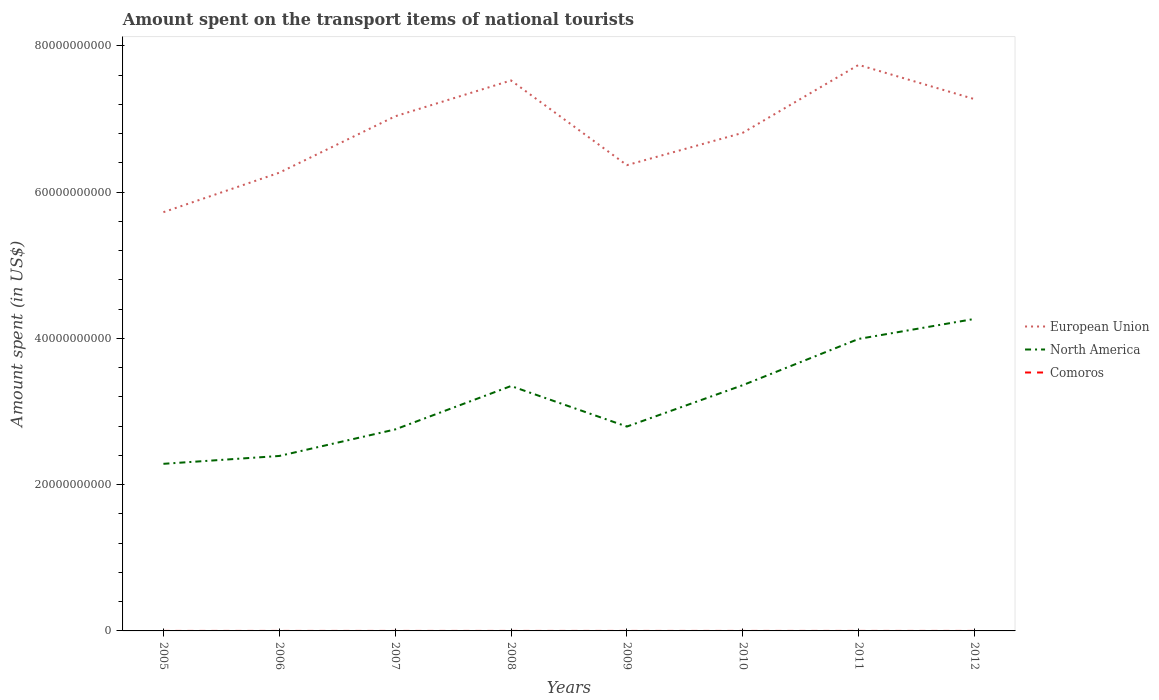Across all years, what is the maximum amount spent on the transport items of national tourists in European Union?
Offer a very short reply. 5.72e+1. In which year was the amount spent on the transport items of national tourists in European Union maximum?
Ensure brevity in your answer.  2005. What is the difference between the highest and the second highest amount spent on the transport items of national tourists in North America?
Offer a very short reply. 1.98e+1. Is the amount spent on the transport items of national tourists in North America strictly greater than the amount spent on the transport items of national tourists in European Union over the years?
Offer a very short reply. Yes. What is the difference between two consecutive major ticks on the Y-axis?
Offer a terse response. 2.00e+1. Are the values on the major ticks of Y-axis written in scientific E-notation?
Your response must be concise. No. Does the graph contain any zero values?
Offer a terse response. No. Does the graph contain grids?
Offer a terse response. No. Where does the legend appear in the graph?
Provide a short and direct response. Center right. How many legend labels are there?
Provide a short and direct response. 3. How are the legend labels stacked?
Your response must be concise. Vertical. What is the title of the graph?
Offer a very short reply. Amount spent on the transport items of national tourists. What is the label or title of the Y-axis?
Offer a very short reply. Amount spent (in US$). What is the Amount spent (in US$) of European Union in 2005?
Provide a short and direct response. 5.72e+1. What is the Amount spent (in US$) in North America in 2005?
Ensure brevity in your answer.  2.28e+1. What is the Amount spent (in US$) in European Union in 2006?
Offer a terse response. 6.26e+1. What is the Amount spent (in US$) in North America in 2006?
Provide a succinct answer. 2.39e+1. What is the Amount spent (in US$) in Comoros in 2006?
Your answer should be compact. 4.00e+05. What is the Amount spent (in US$) of European Union in 2007?
Provide a short and direct response. 7.04e+1. What is the Amount spent (in US$) in North America in 2007?
Your answer should be very brief. 2.75e+1. What is the Amount spent (in US$) in European Union in 2008?
Keep it short and to the point. 7.53e+1. What is the Amount spent (in US$) of North America in 2008?
Ensure brevity in your answer.  3.35e+1. What is the Amount spent (in US$) of Comoros in 2008?
Offer a very short reply. 4.00e+05. What is the Amount spent (in US$) in European Union in 2009?
Ensure brevity in your answer.  6.37e+1. What is the Amount spent (in US$) of North America in 2009?
Provide a succinct answer. 2.79e+1. What is the Amount spent (in US$) in European Union in 2010?
Keep it short and to the point. 6.81e+1. What is the Amount spent (in US$) in North America in 2010?
Give a very brief answer. 3.36e+1. What is the Amount spent (in US$) in Comoros in 2010?
Give a very brief answer. 2.00e+05. What is the Amount spent (in US$) of European Union in 2011?
Offer a very short reply. 7.74e+1. What is the Amount spent (in US$) in North America in 2011?
Your answer should be very brief. 3.99e+1. What is the Amount spent (in US$) of European Union in 2012?
Your response must be concise. 7.27e+1. What is the Amount spent (in US$) in North America in 2012?
Ensure brevity in your answer.  4.27e+1. Across all years, what is the maximum Amount spent (in US$) of European Union?
Your answer should be compact. 7.74e+1. Across all years, what is the maximum Amount spent (in US$) in North America?
Offer a terse response. 4.27e+1. Across all years, what is the maximum Amount spent (in US$) in Comoros?
Offer a very short reply. 4.00e+05. Across all years, what is the minimum Amount spent (in US$) in European Union?
Give a very brief answer. 5.72e+1. Across all years, what is the minimum Amount spent (in US$) of North America?
Provide a short and direct response. 2.28e+1. Across all years, what is the minimum Amount spent (in US$) of Comoros?
Provide a succinct answer. 2.00e+05. What is the total Amount spent (in US$) of European Union in the graph?
Ensure brevity in your answer.  5.47e+11. What is the total Amount spent (in US$) of North America in the graph?
Offer a terse response. 2.52e+11. What is the total Amount spent (in US$) of Comoros in the graph?
Keep it short and to the point. 2.55e+06. What is the difference between the Amount spent (in US$) of European Union in 2005 and that in 2006?
Provide a short and direct response. -5.40e+09. What is the difference between the Amount spent (in US$) of North America in 2005 and that in 2006?
Ensure brevity in your answer.  -1.07e+09. What is the difference between the Amount spent (in US$) in European Union in 2005 and that in 2007?
Make the answer very short. -1.31e+1. What is the difference between the Amount spent (in US$) of North America in 2005 and that in 2007?
Give a very brief answer. -4.70e+09. What is the difference between the Amount spent (in US$) in Comoros in 2005 and that in 2007?
Your answer should be compact. 0. What is the difference between the Amount spent (in US$) in European Union in 2005 and that in 2008?
Make the answer very short. -1.80e+1. What is the difference between the Amount spent (in US$) of North America in 2005 and that in 2008?
Your answer should be compact. -1.06e+1. What is the difference between the Amount spent (in US$) in Comoros in 2005 and that in 2008?
Your answer should be compact. 0. What is the difference between the Amount spent (in US$) in European Union in 2005 and that in 2009?
Ensure brevity in your answer.  -6.43e+09. What is the difference between the Amount spent (in US$) in North America in 2005 and that in 2009?
Your answer should be very brief. -5.09e+09. What is the difference between the Amount spent (in US$) of European Union in 2005 and that in 2010?
Give a very brief answer. -1.08e+1. What is the difference between the Amount spent (in US$) of North America in 2005 and that in 2010?
Your response must be concise. -1.08e+1. What is the difference between the Amount spent (in US$) in Comoros in 2005 and that in 2010?
Make the answer very short. 2.00e+05. What is the difference between the Amount spent (in US$) in European Union in 2005 and that in 2011?
Make the answer very short. -2.01e+1. What is the difference between the Amount spent (in US$) in North America in 2005 and that in 2011?
Your answer should be very brief. -1.71e+1. What is the difference between the Amount spent (in US$) of European Union in 2005 and that in 2012?
Your answer should be compact. -1.55e+1. What is the difference between the Amount spent (in US$) in North America in 2005 and that in 2012?
Offer a terse response. -1.98e+1. What is the difference between the Amount spent (in US$) of Comoros in 2005 and that in 2012?
Ensure brevity in your answer.  1.00e+05. What is the difference between the Amount spent (in US$) of European Union in 2006 and that in 2007?
Your response must be concise. -7.71e+09. What is the difference between the Amount spent (in US$) in North America in 2006 and that in 2007?
Keep it short and to the point. -3.63e+09. What is the difference between the Amount spent (in US$) in European Union in 2006 and that in 2008?
Your answer should be very brief. -1.26e+1. What is the difference between the Amount spent (in US$) in North America in 2006 and that in 2008?
Make the answer very short. -9.56e+09. What is the difference between the Amount spent (in US$) of European Union in 2006 and that in 2009?
Your answer should be very brief. -1.03e+09. What is the difference between the Amount spent (in US$) of North America in 2006 and that in 2009?
Provide a succinct answer. -4.02e+09. What is the difference between the Amount spent (in US$) of European Union in 2006 and that in 2010?
Make the answer very short. -5.45e+09. What is the difference between the Amount spent (in US$) of North America in 2006 and that in 2010?
Provide a short and direct response. -9.68e+09. What is the difference between the Amount spent (in US$) in Comoros in 2006 and that in 2010?
Give a very brief answer. 2.00e+05. What is the difference between the Amount spent (in US$) in European Union in 2006 and that in 2011?
Keep it short and to the point. -1.47e+1. What is the difference between the Amount spent (in US$) in North America in 2006 and that in 2011?
Your answer should be very brief. -1.60e+1. What is the difference between the Amount spent (in US$) of European Union in 2006 and that in 2012?
Your answer should be compact. -1.01e+1. What is the difference between the Amount spent (in US$) in North America in 2006 and that in 2012?
Give a very brief answer. -1.87e+1. What is the difference between the Amount spent (in US$) in Comoros in 2006 and that in 2012?
Give a very brief answer. 1.00e+05. What is the difference between the Amount spent (in US$) in European Union in 2007 and that in 2008?
Your answer should be compact. -4.90e+09. What is the difference between the Amount spent (in US$) in North America in 2007 and that in 2008?
Make the answer very short. -5.94e+09. What is the difference between the Amount spent (in US$) of Comoros in 2007 and that in 2008?
Offer a very short reply. 0. What is the difference between the Amount spent (in US$) in European Union in 2007 and that in 2009?
Provide a succinct answer. 6.68e+09. What is the difference between the Amount spent (in US$) of North America in 2007 and that in 2009?
Ensure brevity in your answer.  -3.94e+08. What is the difference between the Amount spent (in US$) of European Union in 2007 and that in 2010?
Provide a succinct answer. 2.26e+09. What is the difference between the Amount spent (in US$) in North America in 2007 and that in 2010?
Give a very brief answer. -6.05e+09. What is the difference between the Amount spent (in US$) of Comoros in 2007 and that in 2010?
Offer a terse response. 2.00e+05. What is the difference between the Amount spent (in US$) of European Union in 2007 and that in 2011?
Keep it short and to the point. -7.03e+09. What is the difference between the Amount spent (in US$) of North America in 2007 and that in 2011?
Your answer should be compact. -1.24e+1. What is the difference between the Amount spent (in US$) in Comoros in 2007 and that in 2011?
Your answer should be very brief. 2.00e+05. What is the difference between the Amount spent (in US$) of European Union in 2007 and that in 2012?
Make the answer very short. -2.35e+09. What is the difference between the Amount spent (in US$) in North America in 2007 and that in 2012?
Keep it short and to the point. -1.51e+1. What is the difference between the Amount spent (in US$) in Comoros in 2007 and that in 2012?
Offer a very short reply. 1.00e+05. What is the difference between the Amount spent (in US$) in European Union in 2008 and that in 2009?
Provide a short and direct response. 1.16e+1. What is the difference between the Amount spent (in US$) in North America in 2008 and that in 2009?
Your answer should be compact. 5.54e+09. What is the difference between the Amount spent (in US$) of Comoros in 2008 and that in 2009?
Your response must be concise. 1.50e+05. What is the difference between the Amount spent (in US$) of European Union in 2008 and that in 2010?
Your answer should be compact. 7.16e+09. What is the difference between the Amount spent (in US$) in North America in 2008 and that in 2010?
Your answer should be very brief. -1.16e+08. What is the difference between the Amount spent (in US$) in European Union in 2008 and that in 2011?
Offer a very short reply. -2.13e+09. What is the difference between the Amount spent (in US$) in North America in 2008 and that in 2011?
Offer a terse response. -6.44e+09. What is the difference between the Amount spent (in US$) of European Union in 2008 and that in 2012?
Give a very brief answer. 2.56e+09. What is the difference between the Amount spent (in US$) of North America in 2008 and that in 2012?
Your response must be concise. -9.17e+09. What is the difference between the Amount spent (in US$) of European Union in 2009 and that in 2010?
Keep it short and to the point. -4.42e+09. What is the difference between the Amount spent (in US$) in North America in 2009 and that in 2010?
Offer a very short reply. -5.66e+09. What is the difference between the Amount spent (in US$) of Comoros in 2009 and that in 2010?
Your response must be concise. 5.00e+04. What is the difference between the Amount spent (in US$) of European Union in 2009 and that in 2011?
Keep it short and to the point. -1.37e+1. What is the difference between the Amount spent (in US$) in North America in 2009 and that in 2011?
Offer a very short reply. -1.20e+1. What is the difference between the Amount spent (in US$) in Comoros in 2009 and that in 2011?
Provide a short and direct response. 5.00e+04. What is the difference between the Amount spent (in US$) in European Union in 2009 and that in 2012?
Your answer should be compact. -9.02e+09. What is the difference between the Amount spent (in US$) of North America in 2009 and that in 2012?
Keep it short and to the point. -1.47e+1. What is the difference between the Amount spent (in US$) in European Union in 2010 and that in 2011?
Give a very brief answer. -9.29e+09. What is the difference between the Amount spent (in US$) of North America in 2010 and that in 2011?
Ensure brevity in your answer.  -6.32e+09. What is the difference between the Amount spent (in US$) of Comoros in 2010 and that in 2011?
Your answer should be compact. 0. What is the difference between the Amount spent (in US$) of European Union in 2010 and that in 2012?
Make the answer very short. -4.60e+09. What is the difference between the Amount spent (in US$) of North America in 2010 and that in 2012?
Keep it short and to the point. -9.06e+09. What is the difference between the Amount spent (in US$) of European Union in 2011 and that in 2012?
Offer a terse response. 4.68e+09. What is the difference between the Amount spent (in US$) in North America in 2011 and that in 2012?
Offer a very short reply. -2.73e+09. What is the difference between the Amount spent (in US$) of Comoros in 2011 and that in 2012?
Ensure brevity in your answer.  -1.00e+05. What is the difference between the Amount spent (in US$) in European Union in 2005 and the Amount spent (in US$) in North America in 2006?
Make the answer very short. 3.33e+1. What is the difference between the Amount spent (in US$) in European Union in 2005 and the Amount spent (in US$) in Comoros in 2006?
Keep it short and to the point. 5.72e+1. What is the difference between the Amount spent (in US$) in North America in 2005 and the Amount spent (in US$) in Comoros in 2006?
Ensure brevity in your answer.  2.28e+1. What is the difference between the Amount spent (in US$) of European Union in 2005 and the Amount spent (in US$) of North America in 2007?
Your answer should be very brief. 2.97e+1. What is the difference between the Amount spent (in US$) of European Union in 2005 and the Amount spent (in US$) of Comoros in 2007?
Offer a terse response. 5.72e+1. What is the difference between the Amount spent (in US$) of North America in 2005 and the Amount spent (in US$) of Comoros in 2007?
Provide a short and direct response. 2.28e+1. What is the difference between the Amount spent (in US$) in European Union in 2005 and the Amount spent (in US$) in North America in 2008?
Offer a very short reply. 2.38e+1. What is the difference between the Amount spent (in US$) of European Union in 2005 and the Amount spent (in US$) of Comoros in 2008?
Your answer should be very brief. 5.72e+1. What is the difference between the Amount spent (in US$) of North America in 2005 and the Amount spent (in US$) of Comoros in 2008?
Your answer should be very brief. 2.28e+1. What is the difference between the Amount spent (in US$) in European Union in 2005 and the Amount spent (in US$) in North America in 2009?
Ensure brevity in your answer.  2.93e+1. What is the difference between the Amount spent (in US$) in European Union in 2005 and the Amount spent (in US$) in Comoros in 2009?
Your answer should be very brief. 5.72e+1. What is the difference between the Amount spent (in US$) in North America in 2005 and the Amount spent (in US$) in Comoros in 2009?
Give a very brief answer. 2.28e+1. What is the difference between the Amount spent (in US$) of European Union in 2005 and the Amount spent (in US$) of North America in 2010?
Provide a short and direct response. 2.37e+1. What is the difference between the Amount spent (in US$) of European Union in 2005 and the Amount spent (in US$) of Comoros in 2010?
Give a very brief answer. 5.72e+1. What is the difference between the Amount spent (in US$) of North America in 2005 and the Amount spent (in US$) of Comoros in 2010?
Offer a terse response. 2.28e+1. What is the difference between the Amount spent (in US$) of European Union in 2005 and the Amount spent (in US$) of North America in 2011?
Ensure brevity in your answer.  1.73e+1. What is the difference between the Amount spent (in US$) of European Union in 2005 and the Amount spent (in US$) of Comoros in 2011?
Your answer should be compact. 5.72e+1. What is the difference between the Amount spent (in US$) of North America in 2005 and the Amount spent (in US$) of Comoros in 2011?
Give a very brief answer. 2.28e+1. What is the difference between the Amount spent (in US$) of European Union in 2005 and the Amount spent (in US$) of North America in 2012?
Keep it short and to the point. 1.46e+1. What is the difference between the Amount spent (in US$) in European Union in 2005 and the Amount spent (in US$) in Comoros in 2012?
Your answer should be very brief. 5.72e+1. What is the difference between the Amount spent (in US$) of North America in 2005 and the Amount spent (in US$) of Comoros in 2012?
Offer a very short reply. 2.28e+1. What is the difference between the Amount spent (in US$) in European Union in 2006 and the Amount spent (in US$) in North America in 2007?
Make the answer very short. 3.51e+1. What is the difference between the Amount spent (in US$) of European Union in 2006 and the Amount spent (in US$) of Comoros in 2007?
Provide a succinct answer. 6.26e+1. What is the difference between the Amount spent (in US$) of North America in 2006 and the Amount spent (in US$) of Comoros in 2007?
Keep it short and to the point. 2.39e+1. What is the difference between the Amount spent (in US$) of European Union in 2006 and the Amount spent (in US$) of North America in 2008?
Your answer should be very brief. 2.92e+1. What is the difference between the Amount spent (in US$) of European Union in 2006 and the Amount spent (in US$) of Comoros in 2008?
Offer a terse response. 6.26e+1. What is the difference between the Amount spent (in US$) of North America in 2006 and the Amount spent (in US$) of Comoros in 2008?
Your answer should be compact. 2.39e+1. What is the difference between the Amount spent (in US$) of European Union in 2006 and the Amount spent (in US$) of North America in 2009?
Your response must be concise. 3.47e+1. What is the difference between the Amount spent (in US$) of European Union in 2006 and the Amount spent (in US$) of Comoros in 2009?
Offer a terse response. 6.26e+1. What is the difference between the Amount spent (in US$) of North America in 2006 and the Amount spent (in US$) of Comoros in 2009?
Offer a very short reply. 2.39e+1. What is the difference between the Amount spent (in US$) in European Union in 2006 and the Amount spent (in US$) in North America in 2010?
Offer a terse response. 2.90e+1. What is the difference between the Amount spent (in US$) in European Union in 2006 and the Amount spent (in US$) in Comoros in 2010?
Give a very brief answer. 6.26e+1. What is the difference between the Amount spent (in US$) in North America in 2006 and the Amount spent (in US$) in Comoros in 2010?
Offer a very short reply. 2.39e+1. What is the difference between the Amount spent (in US$) in European Union in 2006 and the Amount spent (in US$) in North America in 2011?
Ensure brevity in your answer.  2.27e+1. What is the difference between the Amount spent (in US$) in European Union in 2006 and the Amount spent (in US$) in Comoros in 2011?
Your answer should be very brief. 6.26e+1. What is the difference between the Amount spent (in US$) in North America in 2006 and the Amount spent (in US$) in Comoros in 2011?
Provide a succinct answer. 2.39e+1. What is the difference between the Amount spent (in US$) of European Union in 2006 and the Amount spent (in US$) of North America in 2012?
Your answer should be very brief. 2.00e+1. What is the difference between the Amount spent (in US$) in European Union in 2006 and the Amount spent (in US$) in Comoros in 2012?
Your answer should be very brief. 6.26e+1. What is the difference between the Amount spent (in US$) of North America in 2006 and the Amount spent (in US$) of Comoros in 2012?
Your answer should be compact. 2.39e+1. What is the difference between the Amount spent (in US$) in European Union in 2007 and the Amount spent (in US$) in North America in 2008?
Keep it short and to the point. 3.69e+1. What is the difference between the Amount spent (in US$) in European Union in 2007 and the Amount spent (in US$) in Comoros in 2008?
Ensure brevity in your answer.  7.04e+1. What is the difference between the Amount spent (in US$) in North America in 2007 and the Amount spent (in US$) in Comoros in 2008?
Your answer should be compact. 2.75e+1. What is the difference between the Amount spent (in US$) in European Union in 2007 and the Amount spent (in US$) in North America in 2009?
Make the answer very short. 4.24e+1. What is the difference between the Amount spent (in US$) in European Union in 2007 and the Amount spent (in US$) in Comoros in 2009?
Keep it short and to the point. 7.04e+1. What is the difference between the Amount spent (in US$) of North America in 2007 and the Amount spent (in US$) of Comoros in 2009?
Your answer should be compact. 2.75e+1. What is the difference between the Amount spent (in US$) of European Union in 2007 and the Amount spent (in US$) of North America in 2010?
Your answer should be compact. 3.68e+1. What is the difference between the Amount spent (in US$) in European Union in 2007 and the Amount spent (in US$) in Comoros in 2010?
Offer a very short reply. 7.04e+1. What is the difference between the Amount spent (in US$) of North America in 2007 and the Amount spent (in US$) of Comoros in 2010?
Offer a very short reply. 2.75e+1. What is the difference between the Amount spent (in US$) of European Union in 2007 and the Amount spent (in US$) of North America in 2011?
Your response must be concise. 3.04e+1. What is the difference between the Amount spent (in US$) of European Union in 2007 and the Amount spent (in US$) of Comoros in 2011?
Keep it short and to the point. 7.04e+1. What is the difference between the Amount spent (in US$) in North America in 2007 and the Amount spent (in US$) in Comoros in 2011?
Give a very brief answer. 2.75e+1. What is the difference between the Amount spent (in US$) in European Union in 2007 and the Amount spent (in US$) in North America in 2012?
Your answer should be very brief. 2.77e+1. What is the difference between the Amount spent (in US$) in European Union in 2007 and the Amount spent (in US$) in Comoros in 2012?
Ensure brevity in your answer.  7.04e+1. What is the difference between the Amount spent (in US$) in North America in 2007 and the Amount spent (in US$) in Comoros in 2012?
Make the answer very short. 2.75e+1. What is the difference between the Amount spent (in US$) in European Union in 2008 and the Amount spent (in US$) in North America in 2009?
Keep it short and to the point. 4.73e+1. What is the difference between the Amount spent (in US$) in European Union in 2008 and the Amount spent (in US$) in Comoros in 2009?
Provide a succinct answer. 7.53e+1. What is the difference between the Amount spent (in US$) in North America in 2008 and the Amount spent (in US$) in Comoros in 2009?
Offer a terse response. 3.35e+1. What is the difference between the Amount spent (in US$) in European Union in 2008 and the Amount spent (in US$) in North America in 2010?
Your answer should be compact. 4.17e+1. What is the difference between the Amount spent (in US$) of European Union in 2008 and the Amount spent (in US$) of Comoros in 2010?
Give a very brief answer. 7.53e+1. What is the difference between the Amount spent (in US$) of North America in 2008 and the Amount spent (in US$) of Comoros in 2010?
Keep it short and to the point. 3.35e+1. What is the difference between the Amount spent (in US$) in European Union in 2008 and the Amount spent (in US$) in North America in 2011?
Your answer should be compact. 3.53e+1. What is the difference between the Amount spent (in US$) of European Union in 2008 and the Amount spent (in US$) of Comoros in 2011?
Make the answer very short. 7.53e+1. What is the difference between the Amount spent (in US$) of North America in 2008 and the Amount spent (in US$) of Comoros in 2011?
Your answer should be compact. 3.35e+1. What is the difference between the Amount spent (in US$) of European Union in 2008 and the Amount spent (in US$) of North America in 2012?
Keep it short and to the point. 3.26e+1. What is the difference between the Amount spent (in US$) of European Union in 2008 and the Amount spent (in US$) of Comoros in 2012?
Your answer should be very brief. 7.53e+1. What is the difference between the Amount spent (in US$) of North America in 2008 and the Amount spent (in US$) of Comoros in 2012?
Your response must be concise. 3.35e+1. What is the difference between the Amount spent (in US$) in European Union in 2009 and the Amount spent (in US$) in North America in 2010?
Your response must be concise. 3.01e+1. What is the difference between the Amount spent (in US$) of European Union in 2009 and the Amount spent (in US$) of Comoros in 2010?
Give a very brief answer. 6.37e+1. What is the difference between the Amount spent (in US$) in North America in 2009 and the Amount spent (in US$) in Comoros in 2010?
Your answer should be compact. 2.79e+1. What is the difference between the Amount spent (in US$) of European Union in 2009 and the Amount spent (in US$) of North America in 2011?
Ensure brevity in your answer.  2.38e+1. What is the difference between the Amount spent (in US$) of European Union in 2009 and the Amount spent (in US$) of Comoros in 2011?
Offer a very short reply. 6.37e+1. What is the difference between the Amount spent (in US$) of North America in 2009 and the Amount spent (in US$) of Comoros in 2011?
Your answer should be very brief. 2.79e+1. What is the difference between the Amount spent (in US$) of European Union in 2009 and the Amount spent (in US$) of North America in 2012?
Give a very brief answer. 2.10e+1. What is the difference between the Amount spent (in US$) of European Union in 2009 and the Amount spent (in US$) of Comoros in 2012?
Make the answer very short. 6.37e+1. What is the difference between the Amount spent (in US$) in North America in 2009 and the Amount spent (in US$) in Comoros in 2012?
Keep it short and to the point. 2.79e+1. What is the difference between the Amount spent (in US$) of European Union in 2010 and the Amount spent (in US$) of North America in 2011?
Your answer should be compact. 2.82e+1. What is the difference between the Amount spent (in US$) of European Union in 2010 and the Amount spent (in US$) of Comoros in 2011?
Ensure brevity in your answer.  6.81e+1. What is the difference between the Amount spent (in US$) in North America in 2010 and the Amount spent (in US$) in Comoros in 2011?
Your answer should be compact. 3.36e+1. What is the difference between the Amount spent (in US$) of European Union in 2010 and the Amount spent (in US$) of North America in 2012?
Ensure brevity in your answer.  2.54e+1. What is the difference between the Amount spent (in US$) of European Union in 2010 and the Amount spent (in US$) of Comoros in 2012?
Provide a short and direct response. 6.81e+1. What is the difference between the Amount spent (in US$) of North America in 2010 and the Amount spent (in US$) of Comoros in 2012?
Give a very brief answer. 3.36e+1. What is the difference between the Amount spent (in US$) in European Union in 2011 and the Amount spent (in US$) in North America in 2012?
Ensure brevity in your answer.  3.47e+1. What is the difference between the Amount spent (in US$) of European Union in 2011 and the Amount spent (in US$) of Comoros in 2012?
Offer a terse response. 7.74e+1. What is the difference between the Amount spent (in US$) in North America in 2011 and the Amount spent (in US$) in Comoros in 2012?
Your response must be concise. 3.99e+1. What is the average Amount spent (in US$) of European Union per year?
Provide a succinct answer. 6.84e+1. What is the average Amount spent (in US$) of North America per year?
Your answer should be very brief. 3.15e+1. What is the average Amount spent (in US$) in Comoros per year?
Make the answer very short. 3.19e+05. In the year 2005, what is the difference between the Amount spent (in US$) in European Union and Amount spent (in US$) in North America?
Make the answer very short. 3.44e+1. In the year 2005, what is the difference between the Amount spent (in US$) in European Union and Amount spent (in US$) in Comoros?
Offer a terse response. 5.72e+1. In the year 2005, what is the difference between the Amount spent (in US$) of North America and Amount spent (in US$) of Comoros?
Make the answer very short. 2.28e+1. In the year 2006, what is the difference between the Amount spent (in US$) in European Union and Amount spent (in US$) in North America?
Offer a very short reply. 3.87e+1. In the year 2006, what is the difference between the Amount spent (in US$) of European Union and Amount spent (in US$) of Comoros?
Offer a very short reply. 6.26e+1. In the year 2006, what is the difference between the Amount spent (in US$) of North America and Amount spent (in US$) of Comoros?
Offer a terse response. 2.39e+1. In the year 2007, what is the difference between the Amount spent (in US$) of European Union and Amount spent (in US$) of North America?
Provide a short and direct response. 4.28e+1. In the year 2007, what is the difference between the Amount spent (in US$) in European Union and Amount spent (in US$) in Comoros?
Provide a short and direct response. 7.04e+1. In the year 2007, what is the difference between the Amount spent (in US$) in North America and Amount spent (in US$) in Comoros?
Your response must be concise. 2.75e+1. In the year 2008, what is the difference between the Amount spent (in US$) in European Union and Amount spent (in US$) in North America?
Make the answer very short. 4.18e+1. In the year 2008, what is the difference between the Amount spent (in US$) in European Union and Amount spent (in US$) in Comoros?
Offer a very short reply. 7.53e+1. In the year 2008, what is the difference between the Amount spent (in US$) of North America and Amount spent (in US$) of Comoros?
Your response must be concise. 3.35e+1. In the year 2009, what is the difference between the Amount spent (in US$) in European Union and Amount spent (in US$) in North America?
Ensure brevity in your answer.  3.57e+1. In the year 2009, what is the difference between the Amount spent (in US$) of European Union and Amount spent (in US$) of Comoros?
Ensure brevity in your answer.  6.37e+1. In the year 2009, what is the difference between the Amount spent (in US$) of North America and Amount spent (in US$) of Comoros?
Provide a short and direct response. 2.79e+1. In the year 2010, what is the difference between the Amount spent (in US$) in European Union and Amount spent (in US$) in North America?
Offer a very short reply. 3.45e+1. In the year 2010, what is the difference between the Amount spent (in US$) of European Union and Amount spent (in US$) of Comoros?
Your answer should be compact. 6.81e+1. In the year 2010, what is the difference between the Amount spent (in US$) in North America and Amount spent (in US$) in Comoros?
Provide a succinct answer. 3.36e+1. In the year 2011, what is the difference between the Amount spent (in US$) of European Union and Amount spent (in US$) of North America?
Your answer should be very brief. 3.75e+1. In the year 2011, what is the difference between the Amount spent (in US$) in European Union and Amount spent (in US$) in Comoros?
Your answer should be very brief. 7.74e+1. In the year 2011, what is the difference between the Amount spent (in US$) of North America and Amount spent (in US$) of Comoros?
Provide a short and direct response. 3.99e+1. In the year 2012, what is the difference between the Amount spent (in US$) in European Union and Amount spent (in US$) in North America?
Your response must be concise. 3.00e+1. In the year 2012, what is the difference between the Amount spent (in US$) in European Union and Amount spent (in US$) in Comoros?
Provide a short and direct response. 7.27e+1. In the year 2012, what is the difference between the Amount spent (in US$) of North America and Amount spent (in US$) of Comoros?
Your response must be concise. 4.27e+1. What is the ratio of the Amount spent (in US$) of European Union in 2005 to that in 2006?
Offer a very short reply. 0.91. What is the ratio of the Amount spent (in US$) in North America in 2005 to that in 2006?
Your response must be concise. 0.96. What is the ratio of the Amount spent (in US$) of European Union in 2005 to that in 2007?
Your answer should be compact. 0.81. What is the ratio of the Amount spent (in US$) in North America in 2005 to that in 2007?
Make the answer very short. 0.83. What is the ratio of the Amount spent (in US$) in Comoros in 2005 to that in 2007?
Your response must be concise. 1. What is the ratio of the Amount spent (in US$) in European Union in 2005 to that in 2008?
Give a very brief answer. 0.76. What is the ratio of the Amount spent (in US$) in North America in 2005 to that in 2008?
Your answer should be very brief. 0.68. What is the ratio of the Amount spent (in US$) of European Union in 2005 to that in 2009?
Provide a short and direct response. 0.9. What is the ratio of the Amount spent (in US$) of North America in 2005 to that in 2009?
Offer a terse response. 0.82. What is the ratio of the Amount spent (in US$) of European Union in 2005 to that in 2010?
Offer a terse response. 0.84. What is the ratio of the Amount spent (in US$) in North America in 2005 to that in 2010?
Make the answer very short. 0.68. What is the ratio of the Amount spent (in US$) in European Union in 2005 to that in 2011?
Make the answer very short. 0.74. What is the ratio of the Amount spent (in US$) of North America in 2005 to that in 2011?
Your answer should be very brief. 0.57. What is the ratio of the Amount spent (in US$) of European Union in 2005 to that in 2012?
Make the answer very short. 0.79. What is the ratio of the Amount spent (in US$) of North America in 2005 to that in 2012?
Your answer should be compact. 0.54. What is the ratio of the Amount spent (in US$) in Comoros in 2005 to that in 2012?
Provide a short and direct response. 1.33. What is the ratio of the Amount spent (in US$) in European Union in 2006 to that in 2007?
Your answer should be very brief. 0.89. What is the ratio of the Amount spent (in US$) of North America in 2006 to that in 2007?
Your answer should be compact. 0.87. What is the ratio of the Amount spent (in US$) of European Union in 2006 to that in 2008?
Make the answer very short. 0.83. What is the ratio of the Amount spent (in US$) in North America in 2006 to that in 2008?
Your answer should be compact. 0.71. What is the ratio of the Amount spent (in US$) of Comoros in 2006 to that in 2008?
Provide a short and direct response. 1. What is the ratio of the Amount spent (in US$) in European Union in 2006 to that in 2009?
Make the answer very short. 0.98. What is the ratio of the Amount spent (in US$) of North America in 2006 to that in 2009?
Your answer should be very brief. 0.86. What is the ratio of the Amount spent (in US$) of Comoros in 2006 to that in 2009?
Keep it short and to the point. 1.6. What is the ratio of the Amount spent (in US$) in European Union in 2006 to that in 2010?
Provide a short and direct response. 0.92. What is the ratio of the Amount spent (in US$) in North America in 2006 to that in 2010?
Provide a succinct answer. 0.71. What is the ratio of the Amount spent (in US$) of European Union in 2006 to that in 2011?
Ensure brevity in your answer.  0.81. What is the ratio of the Amount spent (in US$) of North America in 2006 to that in 2011?
Give a very brief answer. 0.6. What is the ratio of the Amount spent (in US$) of Comoros in 2006 to that in 2011?
Keep it short and to the point. 2. What is the ratio of the Amount spent (in US$) in European Union in 2006 to that in 2012?
Provide a succinct answer. 0.86. What is the ratio of the Amount spent (in US$) in North America in 2006 to that in 2012?
Your response must be concise. 0.56. What is the ratio of the Amount spent (in US$) of European Union in 2007 to that in 2008?
Offer a very short reply. 0.93. What is the ratio of the Amount spent (in US$) in North America in 2007 to that in 2008?
Make the answer very short. 0.82. What is the ratio of the Amount spent (in US$) of European Union in 2007 to that in 2009?
Offer a terse response. 1.1. What is the ratio of the Amount spent (in US$) of North America in 2007 to that in 2009?
Give a very brief answer. 0.99. What is the ratio of the Amount spent (in US$) in Comoros in 2007 to that in 2009?
Offer a very short reply. 1.6. What is the ratio of the Amount spent (in US$) in European Union in 2007 to that in 2010?
Provide a succinct answer. 1.03. What is the ratio of the Amount spent (in US$) in North America in 2007 to that in 2010?
Ensure brevity in your answer.  0.82. What is the ratio of the Amount spent (in US$) of Comoros in 2007 to that in 2010?
Keep it short and to the point. 2. What is the ratio of the Amount spent (in US$) of European Union in 2007 to that in 2011?
Provide a succinct answer. 0.91. What is the ratio of the Amount spent (in US$) in North America in 2007 to that in 2011?
Provide a succinct answer. 0.69. What is the ratio of the Amount spent (in US$) of Comoros in 2007 to that in 2011?
Keep it short and to the point. 2. What is the ratio of the Amount spent (in US$) of North America in 2007 to that in 2012?
Ensure brevity in your answer.  0.65. What is the ratio of the Amount spent (in US$) in Comoros in 2007 to that in 2012?
Keep it short and to the point. 1.33. What is the ratio of the Amount spent (in US$) in European Union in 2008 to that in 2009?
Provide a short and direct response. 1.18. What is the ratio of the Amount spent (in US$) of North America in 2008 to that in 2009?
Your response must be concise. 1.2. What is the ratio of the Amount spent (in US$) of Comoros in 2008 to that in 2009?
Your response must be concise. 1.6. What is the ratio of the Amount spent (in US$) of European Union in 2008 to that in 2010?
Make the answer very short. 1.11. What is the ratio of the Amount spent (in US$) in North America in 2008 to that in 2010?
Provide a succinct answer. 1. What is the ratio of the Amount spent (in US$) of European Union in 2008 to that in 2011?
Keep it short and to the point. 0.97. What is the ratio of the Amount spent (in US$) of North America in 2008 to that in 2011?
Your answer should be very brief. 0.84. What is the ratio of the Amount spent (in US$) of Comoros in 2008 to that in 2011?
Make the answer very short. 2. What is the ratio of the Amount spent (in US$) of European Union in 2008 to that in 2012?
Your answer should be compact. 1.04. What is the ratio of the Amount spent (in US$) of North America in 2008 to that in 2012?
Provide a succinct answer. 0.78. What is the ratio of the Amount spent (in US$) in European Union in 2009 to that in 2010?
Provide a succinct answer. 0.94. What is the ratio of the Amount spent (in US$) in North America in 2009 to that in 2010?
Give a very brief answer. 0.83. What is the ratio of the Amount spent (in US$) of European Union in 2009 to that in 2011?
Your answer should be compact. 0.82. What is the ratio of the Amount spent (in US$) in North America in 2009 to that in 2011?
Your answer should be very brief. 0.7. What is the ratio of the Amount spent (in US$) of European Union in 2009 to that in 2012?
Offer a very short reply. 0.88. What is the ratio of the Amount spent (in US$) of North America in 2009 to that in 2012?
Provide a short and direct response. 0.66. What is the ratio of the Amount spent (in US$) of Comoros in 2009 to that in 2012?
Offer a terse response. 0.83. What is the ratio of the Amount spent (in US$) of European Union in 2010 to that in 2011?
Offer a very short reply. 0.88. What is the ratio of the Amount spent (in US$) of North America in 2010 to that in 2011?
Provide a short and direct response. 0.84. What is the ratio of the Amount spent (in US$) in Comoros in 2010 to that in 2011?
Keep it short and to the point. 1. What is the ratio of the Amount spent (in US$) of European Union in 2010 to that in 2012?
Your response must be concise. 0.94. What is the ratio of the Amount spent (in US$) in North America in 2010 to that in 2012?
Your response must be concise. 0.79. What is the ratio of the Amount spent (in US$) in European Union in 2011 to that in 2012?
Your answer should be very brief. 1.06. What is the ratio of the Amount spent (in US$) in North America in 2011 to that in 2012?
Your response must be concise. 0.94. What is the ratio of the Amount spent (in US$) in Comoros in 2011 to that in 2012?
Provide a succinct answer. 0.67. What is the difference between the highest and the second highest Amount spent (in US$) of European Union?
Give a very brief answer. 2.13e+09. What is the difference between the highest and the second highest Amount spent (in US$) in North America?
Provide a succinct answer. 2.73e+09. What is the difference between the highest and the second highest Amount spent (in US$) of Comoros?
Give a very brief answer. 0. What is the difference between the highest and the lowest Amount spent (in US$) of European Union?
Offer a very short reply. 2.01e+1. What is the difference between the highest and the lowest Amount spent (in US$) in North America?
Your response must be concise. 1.98e+1. What is the difference between the highest and the lowest Amount spent (in US$) in Comoros?
Ensure brevity in your answer.  2.00e+05. 